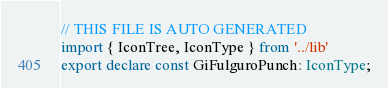<code> <loc_0><loc_0><loc_500><loc_500><_TypeScript_>// THIS FILE IS AUTO GENERATED
import { IconTree, IconType } from '../lib'
export declare const GiFulguroPunch: IconType;
</code> 